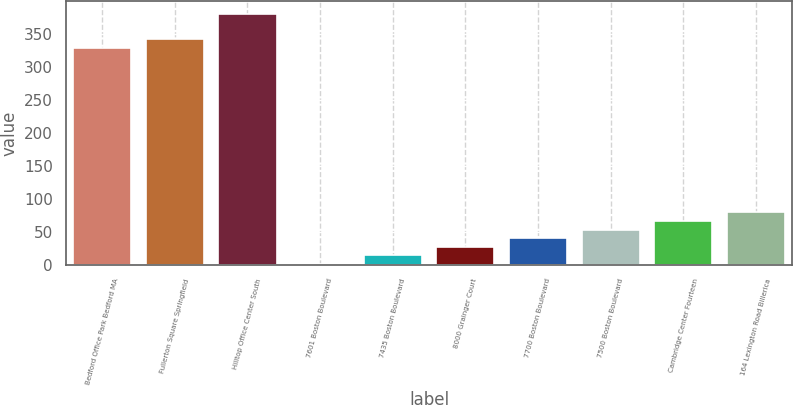Convert chart. <chart><loc_0><loc_0><loc_500><loc_500><bar_chart><fcel>Bedford Office Park Bedford MA<fcel>Fullerton Square Springfield<fcel>Hilltop Office Center South<fcel>7601 Boston Boulevard<fcel>7435 Boston Boulevard<fcel>8000 Grainger Court<fcel>7700 Boston Boulevard<fcel>7500 Boston Boulevard<fcel>Cambridge Center Fourteen<fcel>164 Lexington Road Billerica<nl><fcel>328.5<fcel>341.6<fcel>380.9<fcel>1<fcel>14.1<fcel>27.2<fcel>40.3<fcel>53.4<fcel>66.5<fcel>79.6<nl></chart> 